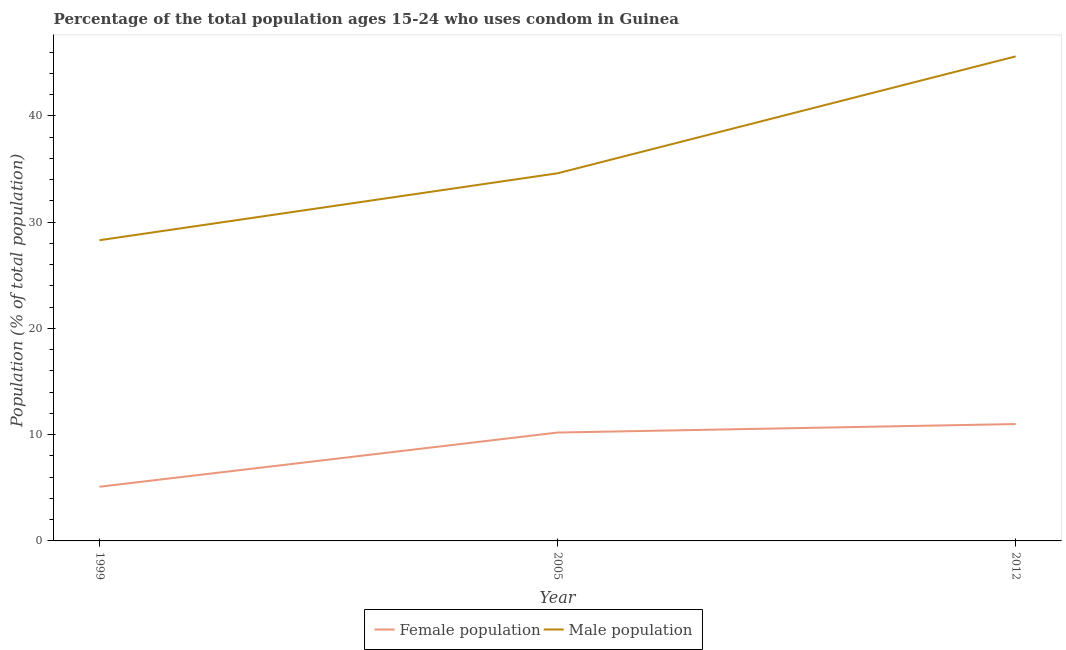How many different coloured lines are there?
Offer a very short reply. 2. Does the line corresponding to male population intersect with the line corresponding to female population?
Your response must be concise. No. In which year was the male population maximum?
Your answer should be very brief. 2012. What is the total male population in the graph?
Ensure brevity in your answer.  108.5. What is the difference between the female population in 2012 and the male population in 1999?
Your response must be concise. -17.3. What is the average male population per year?
Offer a very short reply. 36.17. In the year 2012, what is the difference between the male population and female population?
Make the answer very short. 34.6. What is the ratio of the female population in 2005 to that in 2012?
Offer a terse response. 0.93. Is the male population in 1999 less than that in 2005?
Keep it short and to the point. Yes. What is the difference between the highest and the second highest female population?
Ensure brevity in your answer.  0.8. What is the difference between the highest and the lowest male population?
Keep it short and to the point. 17.3. In how many years, is the female population greater than the average female population taken over all years?
Make the answer very short. 2. Is the sum of the male population in 2005 and 2012 greater than the maximum female population across all years?
Your answer should be compact. Yes. Is the male population strictly greater than the female population over the years?
Your response must be concise. Yes. Is the female population strictly less than the male population over the years?
Make the answer very short. Yes. What is the difference between two consecutive major ticks on the Y-axis?
Provide a short and direct response. 10. Are the values on the major ticks of Y-axis written in scientific E-notation?
Your answer should be very brief. No. Does the graph contain grids?
Your answer should be very brief. No. How many legend labels are there?
Ensure brevity in your answer.  2. What is the title of the graph?
Provide a succinct answer. Percentage of the total population ages 15-24 who uses condom in Guinea. Does "State government" appear as one of the legend labels in the graph?
Provide a short and direct response. No. What is the label or title of the X-axis?
Your answer should be very brief. Year. What is the label or title of the Y-axis?
Provide a short and direct response. Population (% of total population) . What is the Population (% of total population)  of Female population in 1999?
Provide a succinct answer. 5.1. What is the Population (% of total population)  of Male population in 1999?
Keep it short and to the point. 28.3. What is the Population (% of total population)  of Female population in 2005?
Your response must be concise. 10.2. What is the Population (% of total population)  in Male population in 2005?
Provide a short and direct response. 34.6. What is the Population (% of total population)  in Female population in 2012?
Offer a very short reply. 11. What is the Population (% of total population)  of Male population in 2012?
Keep it short and to the point. 45.6. Across all years, what is the maximum Population (% of total population)  in Female population?
Provide a succinct answer. 11. Across all years, what is the maximum Population (% of total population)  of Male population?
Ensure brevity in your answer.  45.6. Across all years, what is the minimum Population (% of total population)  of Female population?
Your answer should be very brief. 5.1. Across all years, what is the minimum Population (% of total population)  in Male population?
Provide a succinct answer. 28.3. What is the total Population (% of total population)  of Female population in the graph?
Make the answer very short. 26.3. What is the total Population (% of total population)  of Male population in the graph?
Ensure brevity in your answer.  108.5. What is the difference between the Population (% of total population)  of Male population in 1999 and that in 2005?
Provide a succinct answer. -6.3. What is the difference between the Population (% of total population)  of Male population in 1999 and that in 2012?
Provide a succinct answer. -17.3. What is the difference between the Population (% of total population)  of Male population in 2005 and that in 2012?
Offer a terse response. -11. What is the difference between the Population (% of total population)  in Female population in 1999 and the Population (% of total population)  in Male population in 2005?
Make the answer very short. -29.5. What is the difference between the Population (% of total population)  of Female population in 1999 and the Population (% of total population)  of Male population in 2012?
Keep it short and to the point. -40.5. What is the difference between the Population (% of total population)  of Female population in 2005 and the Population (% of total population)  of Male population in 2012?
Your answer should be compact. -35.4. What is the average Population (% of total population)  in Female population per year?
Provide a succinct answer. 8.77. What is the average Population (% of total population)  of Male population per year?
Your answer should be very brief. 36.17. In the year 1999, what is the difference between the Population (% of total population)  of Female population and Population (% of total population)  of Male population?
Make the answer very short. -23.2. In the year 2005, what is the difference between the Population (% of total population)  of Female population and Population (% of total population)  of Male population?
Offer a very short reply. -24.4. In the year 2012, what is the difference between the Population (% of total population)  of Female population and Population (% of total population)  of Male population?
Provide a succinct answer. -34.6. What is the ratio of the Population (% of total population)  in Male population in 1999 to that in 2005?
Give a very brief answer. 0.82. What is the ratio of the Population (% of total population)  of Female population in 1999 to that in 2012?
Ensure brevity in your answer.  0.46. What is the ratio of the Population (% of total population)  in Male population in 1999 to that in 2012?
Offer a very short reply. 0.62. What is the ratio of the Population (% of total population)  of Female population in 2005 to that in 2012?
Provide a succinct answer. 0.93. What is the ratio of the Population (% of total population)  of Male population in 2005 to that in 2012?
Provide a short and direct response. 0.76. What is the difference between the highest and the second highest Population (% of total population)  in Male population?
Your response must be concise. 11. What is the difference between the highest and the lowest Population (% of total population)  in Female population?
Provide a short and direct response. 5.9. What is the difference between the highest and the lowest Population (% of total population)  in Male population?
Your answer should be very brief. 17.3. 